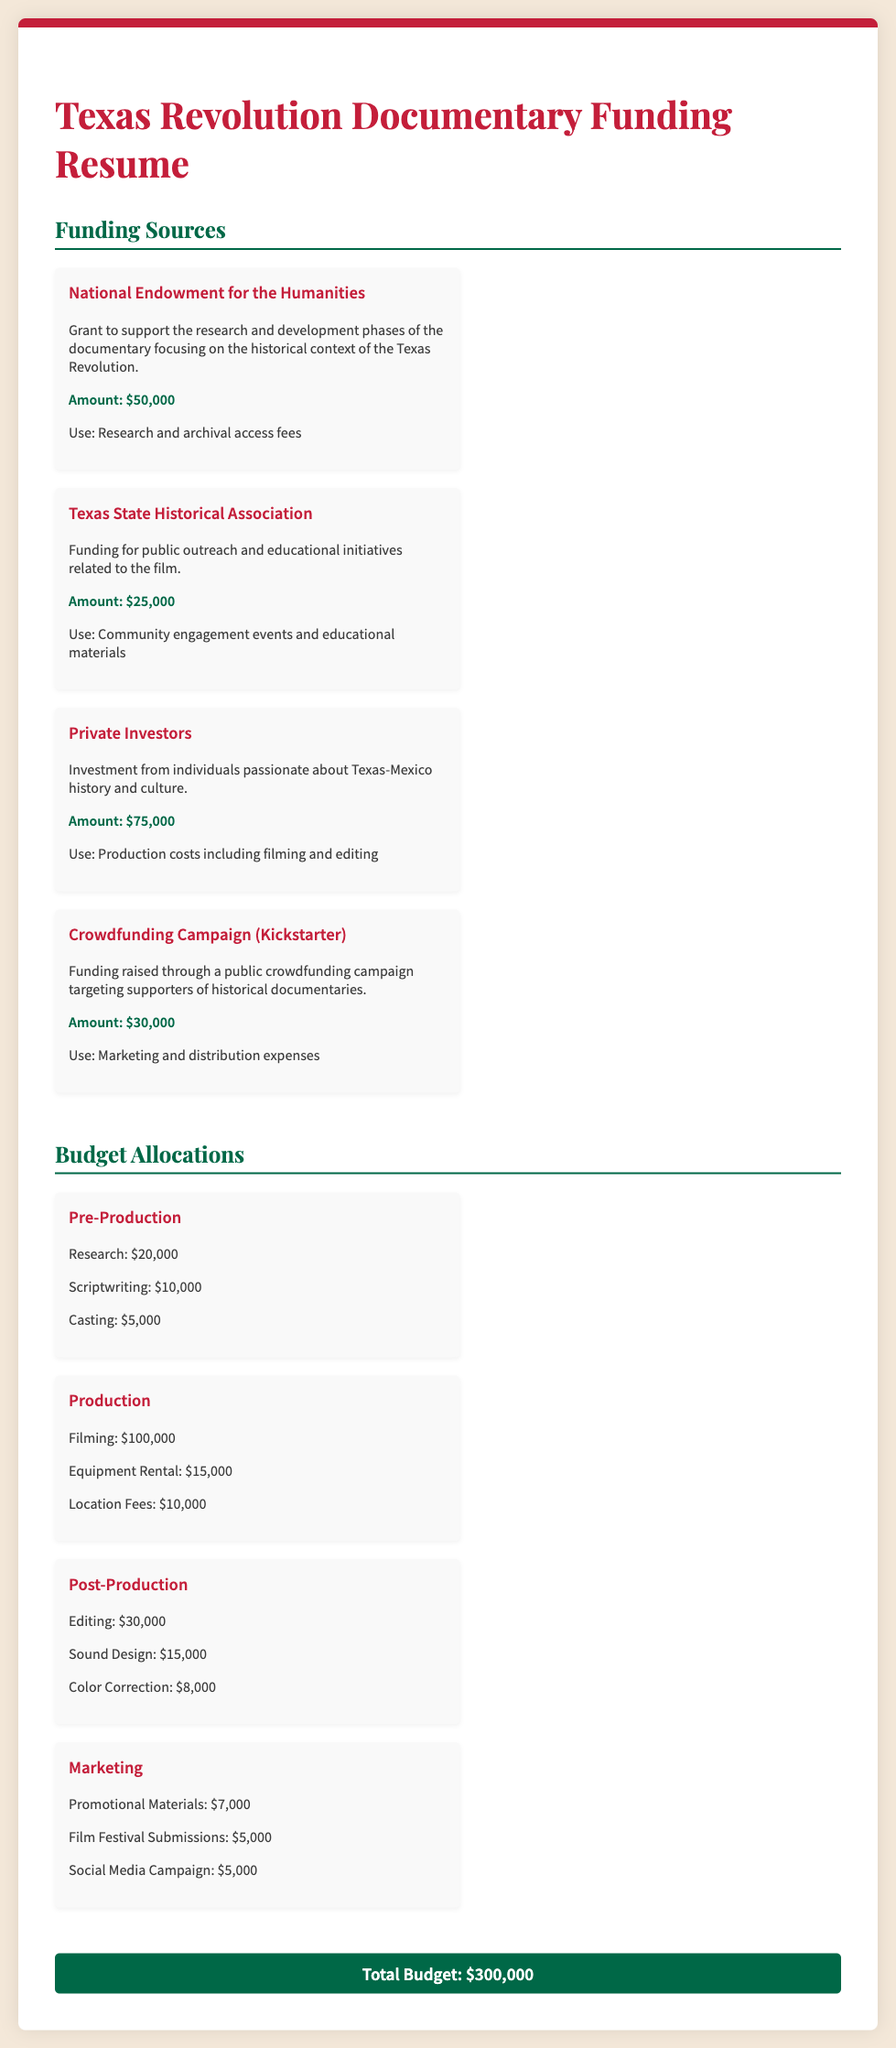what is the total budget? The total budget is stated at the bottom of the document as the sum of the budget allocations, which is $300,000.
Answer: $300,000 how much funding was provided by private investors? The amount provided by private investors is explicitly mentioned in the funding sources section as $75,000.
Answer: $75,000 what is the amount allocated for filming in the production budget? The amount allocated for filming is detailed in the budget allocations section under production, which is $100,000.
Answer: $100,000 which organization provided funding for educational initiatives? The funding source for educational initiatives is the Texas State Historical Association, as mentioned in the funding sources section.
Answer: Texas State Historical Association how much is allocated for social media campaign in marketing? The allocation for the social media campaign is specified as $5,000 in the marketing budget section.
Answer: $5,000 what is the purpose of the crowdfunding campaign mentioned? The crowdfunding campaign is aimed at raising funds for marketing and distribution expenses, as described in the funding sources section.
Answer: Marketing and distribution expenses how much funding was allocated for sound design in post-production? The document states that the allocation for sound design in post-production is $15,000.
Answer: $15,000 what is the total amount of grants received from the National Endowment for the Humanities? The grant amount received from the National Endowment for the Humanities is explicitly mentioned as $50,000.
Answer: $50,000 what are the three main phases listed in the budget allocations? The three main phases listed in the budget allocations are Pre-Production, Production, and Post-Production.
Answer: Pre-Production, Production, Post-Production 